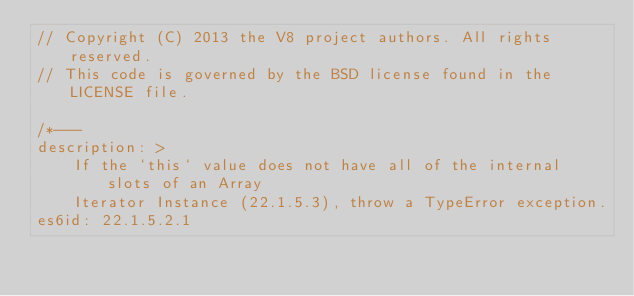Convert code to text. <code><loc_0><loc_0><loc_500><loc_500><_JavaScript_>// Copyright (C) 2013 the V8 project authors. All rights reserved.
// This code is governed by the BSD license found in the LICENSE file.

/*---
description: >
    If the `this` value does not have all of the internal slots of an Array
    Iterator Instance (22.1.5.3), throw a TypeError exception.
es6id: 22.1.5.2.1</code> 